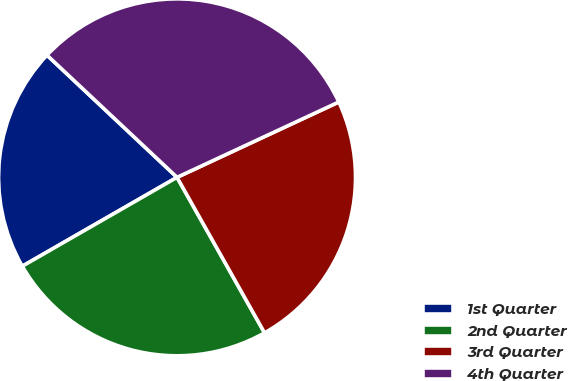Convert chart. <chart><loc_0><loc_0><loc_500><loc_500><pie_chart><fcel>1st Quarter<fcel>2nd Quarter<fcel>3rd Quarter<fcel>4th Quarter<nl><fcel>20.3%<fcel>24.86%<fcel>23.78%<fcel>31.06%<nl></chart> 